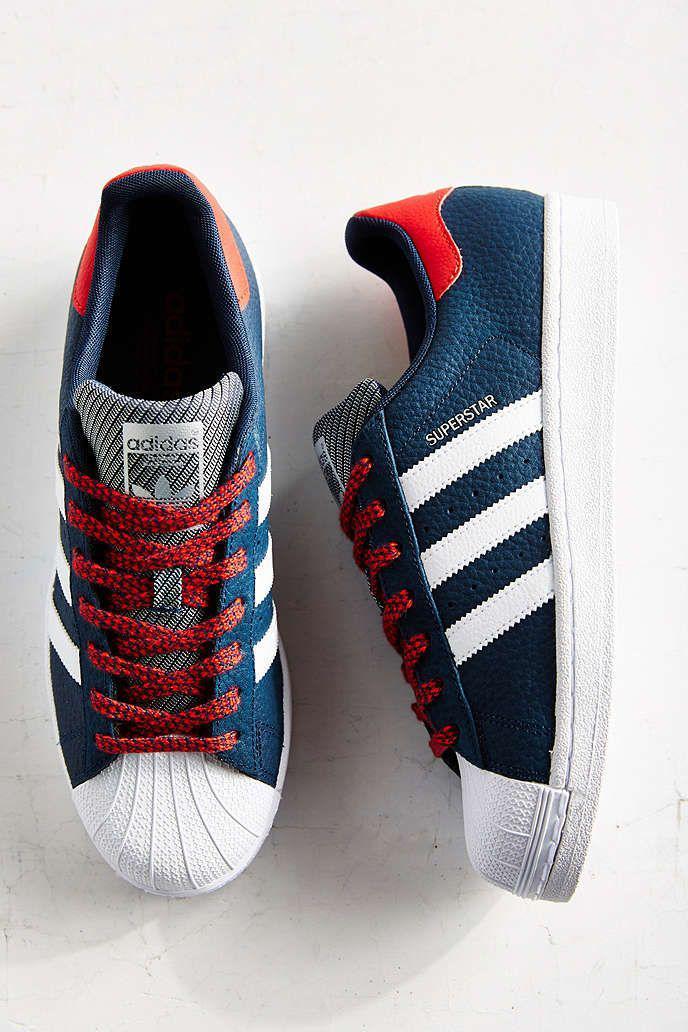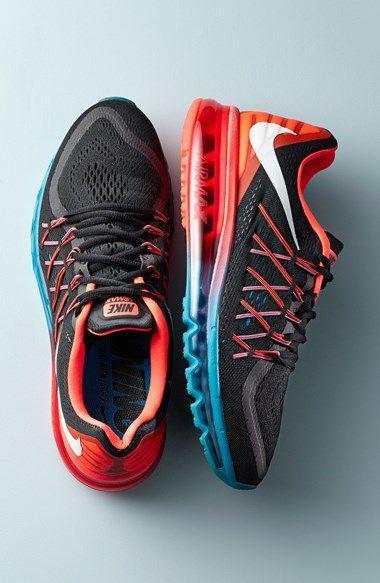The first image is the image on the left, the second image is the image on the right. Assess this claim about the two images: "In the right image, the shoe on the right has a swoop design visible.". Correct or not? Answer yes or no. Yes. 